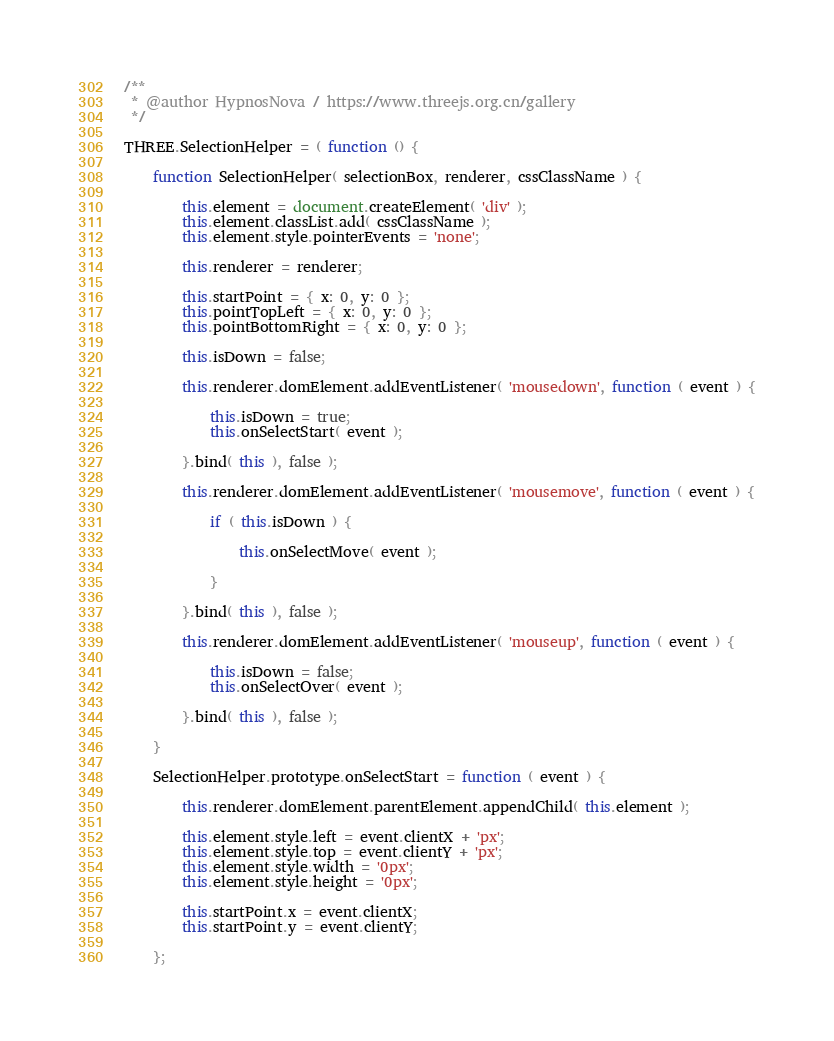<code> <loc_0><loc_0><loc_500><loc_500><_JavaScript_>/**
 * @author HypnosNova / https://www.threejs.org.cn/gallery
 */

THREE.SelectionHelper = ( function () {

	function SelectionHelper( selectionBox, renderer, cssClassName ) {

		this.element = document.createElement( 'div' );
		this.element.classList.add( cssClassName );
		this.element.style.pointerEvents = 'none';

		this.renderer = renderer;

		this.startPoint = { x: 0, y: 0 };
		this.pointTopLeft = { x: 0, y: 0 };
		this.pointBottomRight = { x: 0, y: 0 };

		this.isDown = false;

		this.renderer.domElement.addEventListener( 'mousedown', function ( event ) {

			this.isDown = true;
			this.onSelectStart( event );

		}.bind( this ), false );

		this.renderer.domElement.addEventListener( 'mousemove', function ( event ) {

			if ( this.isDown ) {

				this.onSelectMove( event );

			}

		}.bind( this ), false );

		this.renderer.domElement.addEventListener( 'mouseup', function ( event ) {

			this.isDown = false;
			this.onSelectOver( event );

		}.bind( this ), false );

	}

	SelectionHelper.prototype.onSelectStart = function ( event ) {

		this.renderer.domElement.parentElement.appendChild( this.element );

		this.element.style.left = event.clientX + 'px';
		this.element.style.top = event.clientY + 'px';
		this.element.style.width = '0px';
		this.element.style.height = '0px';

		this.startPoint.x = event.clientX;
		this.startPoint.y = event.clientY;

	};
</code> 